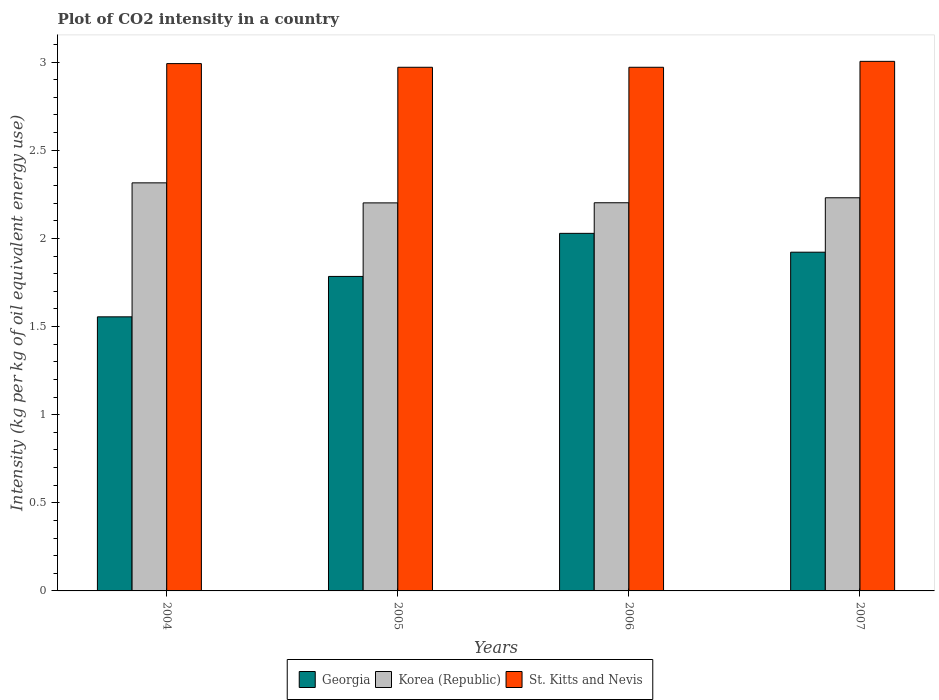How many different coloured bars are there?
Make the answer very short. 3. Are the number of bars per tick equal to the number of legend labels?
Keep it short and to the point. Yes. What is the label of the 2nd group of bars from the left?
Your answer should be compact. 2005. What is the CO2 intensity in in St. Kitts and Nevis in 2004?
Offer a terse response. 2.99. Across all years, what is the maximum CO2 intensity in in Korea (Republic)?
Provide a succinct answer. 2.32. Across all years, what is the minimum CO2 intensity in in Georgia?
Give a very brief answer. 1.55. In which year was the CO2 intensity in in Korea (Republic) minimum?
Offer a very short reply. 2005. What is the total CO2 intensity in in St. Kitts and Nevis in the graph?
Make the answer very short. 11.94. What is the difference between the CO2 intensity in in Georgia in 2004 and that in 2005?
Your response must be concise. -0.23. What is the difference between the CO2 intensity in in Georgia in 2005 and the CO2 intensity in in St. Kitts and Nevis in 2006?
Provide a short and direct response. -1.19. What is the average CO2 intensity in in Korea (Republic) per year?
Offer a terse response. 2.24. In the year 2004, what is the difference between the CO2 intensity in in St. Kitts and Nevis and CO2 intensity in in Korea (Republic)?
Offer a very short reply. 0.68. In how many years, is the CO2 intensity in in Korea (Republic) greater than 2.9 kg?
Keep it short and to the point. 0. What is the ratio of the CO2 intensity in in Korea (Republic) in 2004 to that in 2006?
Provide a short and direct response. 1.05. Is the difference between the CO2 intensity in in St. Kitts and Nevis in 2005 and 2006 greater than the difference between the CO2 intensity in in Korea (Republic) in 2005 and 2006?
Provide a short and direct response. Yes. What is the difference between the highest and the second highest CO2 intensity in in St. Kitts and Nevis?
Your response must be concise. 0.01. What is the difference between the highest and the lowest CO2 intensity in in Korea (Republic)?
Your answer should be very brief. 0.11. In how many years, is the CO2 intensity in in St. Kitts and Nevis greater than the average CO2 intensity in in St. Kitts and Nevis taken over all years?
Your answer should be compact. 2. What does the 1st bar from the left in 2007 represents?
Make the answer very short. Georgia. What does the 3rd bar from the right in 2007 represents?
Provide a succinct answer. Georgia. How many bars are there?
Provide a short and direct response. 12. Are all the bars in the graph horizontal?
Ensure brevity in your answer.  No. How many years are there in the graph?
Your answer should be very brief. 4. Are the values on the major ticks of Y-axis written in scientific E-notation?
Offer a very short reply. No. Does the graph contain grids?
Provide a succinct answer. No. How are the legend labels stacked?
Provide a succinct answer. Horizontal. What is the title of the graph?
Your answer should be very brief. Plot of CO2 intensity in a country. Does "Cambodia" appear as one of the legend labels in the graph?
Make the answer very short. No. What is the label or title of the Y-axis?
Keep it short and to the point. Intensity (kg per kg of oil equivalent energy use). What is the Intensity (kg per kg of oil equivalent energy use) of Georgia in 2004?
Your answer should be compact. 1.55. What is the Intensity (kg per kg of oil equivalent energy use) in Korea (Republic) in 2004?
Your answer should be very brief. 2.32. What is the Intensity (kg per kg of oil equivalent energy use) in St. Kitts and Nevis in 2004?
Offer a terse response. 2.99. What is the Intensity (kg per kg of oil equivalent energy use) in Georgia in 2005?
Ensure brevity in your answer.  1.78. What is the Intensity (kg per kg of oil equivalent energy use) in Korea (Republic) in 2005?
Provide a short and direct response. 2.2. What is the Intensity (kg per kg of oil equivalent energy use) of St. Kitts and Nevis in 2005?
Provide a succinct answer. 2.97. What is the Intensity (kg per kg of oil equivalent energy use) in Georgia in 2006?
Make the answer very short. 2.03. What is the Intensity (kg per kg of oil equivalent energy use) in Korea (Republic) in 2006?
Ensure brevity in your answer.  2.2. What is the Intensity (kg per kg of oil equivalent energy use) in St. Kitts and Nevis in 2006?
Make the answer very short. 2.97. What is the Intensity (kg per kg of oil equivalent energy use) in Georgia in 2007?
Provide a succinct answer. 1.92. What is the Intensity (kg per kg of oil equivalent energy use) of Korea (Republic) in 2007?
Keep it short and to the point. 2.23. What is the Intensity (kg per kg of oil equivalent energy use) of St. Kitts and Nevis in 2007?
Offer a terse response. 3. Across all years, what is the maximum Intensity (kg per kg of oil equivalent energy use) of Georgia?
Your answer should be compact. 2.03. Across all years, what is the maximum Intensity (kg per kg of oil equivalent energy use) in Korea (Republic)?
Ensure brevity in your answer.  2.32. Across all years, what is the maximum Intensity (kg per kg of oil equivalent energy use) in St. Kitts and Nevis?
Give a very brief answer. 3. Across all years, what is the minimum Intensity (kg per kg of oil equivalent energy use) in Georgia?
Make the answer very short. 1.55. Across all years, what is the minimum Intensity (kg per kg of oil equivalent energy use) in Korea (Republic)?
Ensure brevity in your answer.  2.2. Across all years, what is the minimum Intensity (kg per kg of oil equivalent energy use) in St. Kitts and Nevis?
Ensure brevity in your answer.  2.97. What is the total Intensity (kg per kg of oil equivalent energy use) in Georgia in the graph?
Ensure brevity in your answer.  7.29. What is the total Intensity (kg per kg of oil equivalent energy use) in Korea (Republic) in the graph?
Keep it short and to the point. 8.95. What is the total Intensity (kg per kg of oil equivalent energy use) in St. Kitts and Nevis in the graph?
Keep it short and to the point. 11.94. What is the difference between the Intensity (kg per kg of oil equivalent energy use) in Georgia in 2004 and that in 2005?
Offer a very short reply. -0.23. What is the difference between the Intensity (kg per kg of oil equivalent energy use) in Korea (Republic) in 2004 and that in 2005?
Provide a succinct answer. 0.11. What is the difference between the Intensity (kg per kg of oil equivalent energy use) of St. Kitts and Nevis in 2004 and that in 2005?
Ensure brevity in your answer.  0.02. What is the difference between the Intensity (kg per kg of oil equivalent energy use) in Georgia in 2004 and that in 2006?
Offer a terse response. -0.47. What is the difference between the Intensity (kg per kg of oil equivalent energy use) of Korea (Republic) in 2004 and that in 2006?
Your answer should be compact. 0.11. What is the difference between the Intensity (kg per kg of oil equivalent energy use) in St. Kitts and Nevis in 2004 and that in 2006?
Your answer should be compact. 0.02. What is the difference between the Intensity (kg per kg of oil equivalent energy use) of Georgia in 2004 and that in 2007?
Offer a very short reply. -0.37. What is the difference between the Intensity (kg per kg of oil equivalent energy use) in Korea (Republic) in 2004 and that in 2007?
Offer a terse response. 0.08. What is the difference between the Intensity (kg per kg of oil equivalent energy use) of St. Kitts and Nevis in 2004 and that in 2007?
Your answer should be very brief. -0.01. What is the difference between the Intensity (kg per kg of oil equivalent energy use) in Georgia in 2005 and that in 2006?
Make the answer very short. -0.24. What is the difference between the Intensity (kg per kg of oil equivalent energy use) of Korea (Republic) in 2005 and that in 2006?
Give a very brief answer. -0. What is the difference between the Intensity (kg per kg of oil equivalent energy use) of Georgia in 2005 and that in 2007?
Ensure brevity in your answer.  -0.14. What is the difference between the Intensity (kg per kg of oil equivalent energy use) of Korea (Republic) in 2005 and that in 2007?
Keep it short and to the point. -0.03. What is the difference between the Intensity (kg per kg of oil equivalent energy use) in St. Kitts and Nevis in 2005 and that in 2007?
Your response must be concise. -0.03. What is the difference between the Intensity (kg per kg of oil equivalent energy use) in Georgia in 2006 and that in 2007?
Offer a very short reply. 0.11. What is the difference between the Intensity (kg per kg of oil equivalent energy use) of Korea (Republic) in 2006 and that in 2007?
Your response must be concise. -0.03. What is the difference between the Intensity (kg per kg of oil equivalent energy use) of St. Kitts and Nevis in 2006 and that in 2007?
Keep it short and to the point. -0.03. What is the difference between the Intensity (kg per kg of oil equivalent energy use) of Georgia in 2004 and the Intensity (kg per kg of oil equivalent energy use) of Korea (Republic) in 2005?
Offer a terse response. -0.65. What is the difference between the Intensity (kg per kg of oil equivalent energy use) of Georgia in 2004 and the Intensity (kg per kg of oil equivalent energy use) of St. Kitts and Nevis in 2005?
Offer a terse response. -1.42. What is the difference between the Intensity (kg per kg of oil equivalent energy use) of Korea (Republic) in 2004 and the Intensity (kg per kg of oil equivalent energy use) of St. Kitts and Nevis in 2005?
Give a very brief answer. -0.66. What is the difference between the Intensity (kg per kg of oil equivalent energy use) of Georgia in 2004 and the Intensity (kg per kg of oil equivalent energy use) of Korea (Republic) in 2006?
Offer a very short reply. -0.65. What is the difference between the Intensity (kg per kg of oil equivalent energy use) of Georgia in 2004 and the Intensity (kg per kg of oil equivalent energy use) of St. Kitts and Nevis in 2006?
Give a very brief answer. -1.42. What is the difference between the Intensity (kg per kg of oil equivalent energy use) in Korea (Republic) in 2004 and the Intensity (kg per kg of oil equivalent energy use) in St. Kitts and Nevis in 2006?
Make the answer very short. -0.66. What is the difference between the Intensity (kg per kg of oil equivalent energy use) in Georgia in 2004 and the Intensity (kg per kg of oil equivalent energy use) in Korea (Republic) in 2007?
Offer a terse response. -0.68. What is the difference between the Intensity (kg per kg of oil equivalent energy use) in Georgia in 2004 and the Intensity (kg per kg of oil equivalent energy use) in St. Kitts and Nevis in 2007?
Offer a very short reply. -1.45. What is the difference between the Intensity (kg per kg of oil equivalent energy use) in Korea (Republic) in 2004 and the Intensity (kg per kg of oil equivalent energy use) in St. Kitts and Nevis in 2007?
Make the answer very short. -0.69. What is the difference between the Intensity (kg per kg of oil equivalent energy use) of Georgia in 2005 and the Intensity (kg per kg of oil equivalent energy use) of Korea (Republic) in 2006?
Your response must be concise. -0.42. What is the difference between the Intensity (kg per kg of oil equivalent energy use) in Georgia in 2005 and the Intensity (kg per kg of oil equivalent energy use) in St. Kitts and Nevis in 2006?
Ensure brevity in your answer.  -1.19. What is the difference between the Intensity (kg per kg of oil equivalent energy use) of Korea (Republic) in 2005 and the Intensity (kg per kg of oil equivalent energy use) of St. Kitts and Nevis in 2006?
Your answer should be very brief. -0.77. What is the difference between the Intensity (kg per kg of oil equivalent energy use) in Georgia in 2005 and the Intensity (kg per kg of oil equivalent energy use) in Korea (Republic) in 2007?
Offer a terse response. -0.45. What is the difference between the Intensity (kg per kg of oil equivalent energy use) in Georgia in 2005 and the Intensity (kg per kg of oil equivalent energy use) in St. Kitts and Nevis in 2007?
Offer a very short reply. -1.22. What is the difference between the Intensity (kg per kg of oil equivalent energy use) in Korea (Republic) in 2005 and the Intensity (kg per kg of oil equivalent energy use) in St. Kitts and Nevis in 2007?
Provide a succinct answer. -0.8. What is the difference between the Intensity (kg per kg of oil equivalent energy use) in Georgia in 2006 and the Intensity (kg per kg of oil equivalent energy use) in Korea (Republic) in 2007?
Your answer should be very brief. -0.2. What is the difference between the Intensity (kg per kg of oil equivalent energy use) of Georgia in 2006 and the Intensity (kg per kg of oil equivalent energy use) of St. Kitts and Nevis in 2007?
Provide a short and direct response. -0.98. What is the difference between the Intensity (kg per kg of oil equivalent energy use) in Korea (Republic) in 2006 and the Intensity (kg per kg of oil equivalent energy use) in St. Kitts and Nevis in 2007?
Provide a succinct answer. -0.8. What is the average Intensity (kg per kg of oil equivalent energy use) of Georgia per year?
Give a very brief answer. 1.82. What is the average Intensity (kg per kg of oil equivalent energy use) of Korea (Republic) per year?
Give a very brief answer. 2.24. What is the average Intensity (kg per kg of oil equivalent energy use) in St. Kitts and Nevis per year?
Your response must be concise. 2.98. In the year 2004, what is the difference between the Intensity (kg per kg of oil equivalent energy use) of Georgia and Intensity (kg per kg of oil equivalent energy use) of Korea (Republic)?
Make the answer very short. -0.76. In the year 2004, what is the difference between the Intensity (kg per kg of oil equivalent energy use) in Georgia and Intensity (kg per kg of oil equivalent energy use) in St. Kitts and Nevis?
Offer a very short reply. -1.44. In the year 2004, what is the difference between the Intensity (kg per kg of oil equivalent energy use) in Korea (Republic) and Intensity (kg per kg of oil equivalent energy use) in St. Kitts and Nevis?
Offer a terse response. -0.68. In the year 2005, what is the difference between the Intensity (kg per kg of oil equivalent energy use) of Georgia and Intensity (kg per kg of oil equivalent energy use) of Korea (Republic)?
Keep it short and to the point. -0.42. In the year 2005, what is the difference between the Intensity (kg per kg of oil equivalent energy use) of Georgia and Intensity (kg per kg of oil equivalent energy use) of St. Kitts and Nevis?
Offer a terse response. -1.19. In the year 2005, what is the difference between the Intensity (kg per kg of oil equivalent energy use) of Korea (Republic) and Intensity (kg per kg of oil equivalent energy use) of St. Kitts and Nevis?
Your answer should be very brief. -0.77. In the year 2006, what is the difference between the Intensity (kg per kg of oil equivalent energy use) of Georgia and Intensity (kg per kg of oil equivalent energy use) of Korea (Republic)?
Make the answer very short. -0.17. In the year 2006, what is the difference between the Intensity (kg per kg of oil equivalent energy use) in Georgia and Intensity (kg per kg of oil equivalent energy use) in St. Kitts and Nevis?
Make the answer very short. -0.94. In the year 2006, what is the difference between the Intensity (kg per kg of oil equivalent energy use) in Korea (Republic) and Intensity (kg per kg of oil equivalent energy use) in St. Kitts and Nevis?
Offer a terse response. -0.77. In the year 2007, what is the difference between the Intensity (kg per kg of oil equivalent energy use) of Georgia and Intensity (kg per kg of oil equivalent energy use) of Korea (Republic)?
Give a very brief answer. -0.31. In the year 2007, what is the difference between the Intensity (kg per kg of oil equivalent energy use) of Georgia and Intensity (kg per kg of oil equivalent energy use) of St. Kitts and Nevis?
Give a very brief answer. -1.08. In the year 2007, what is the difference between the Intensity (kg per kg of oil equivalent energy use) in Korea (Republic) and Intensity (kg per kg of oil equivalent energy use) in St. Kitts and Nevis?
Your answer should be very brief. -0.77. What is the ratio of the Intensity (kg per kg of oil equivalent energy use) in Georgia in 2004 to that in 2005?
Your response must be concise. 0.87. What is the ratio of the Intensity (kg per kg of oil equivalent energy use) of Korea (Republic) in 2004 to that in 2005?
Your answer should be very brief. 1.05. What is the ratio of the Intensity (kg per kg of oil equivalent energy use) of St. Kitts and Nevis in 2004 to that in 2005?
Ensure brevity in your answer.  1.01. What is the ratio of the Intensity (kg per kg of oil equivalent energy use) of Georgia in 2004 to that in 2006?
Offer a terse response. 0.77. What is the ratio of the Intensity (kg per kg of oil equivalent energy use) in Korea (Republic) in 2004 to that in 2006?
Offer a terse response. 1.05. What is the ratio of the Intensity (kg per kg of oil equivalent energy use) in St. Kitts and Nevis in 2004 to that in 2006?
Provide a short and direct response. 1.01. What is the ratio of the Intensity (kg per kg of oil equivalent energy use) of Georgia in 2004 to that in 2007?
Provide a short and direct response. 0.81. What is the ratio of the Intensity (kg per kg of oil equivalent energy use) of Korea (Republic) in 2004 to that in 2007?
Provide a short and direct response. 1.04. What is the ratio of the Intensity (kg per kg of oil equivalent energy use) of Georgia in 2005 to that in 2006?
Provide a succinct answer. 0.88. What is the ratio of the Intensity (kg per kg of oil equivalent energy use) of Korea (Republic) in 2005 to that in 2006?
Offer a terse response. 1. What is the ratio of the Intensity (kg per kg of oil equivalent energy use) of Georgia in 2005 to that in 2007?
Offer a terse response. 0.93. What is the ratio of the Intensity (kg per kg of oil equivalent energy use) in Georgia in 2006 to that in 2007?
Provide a succinct answer. 1.06. What is the ratio of the Intensity (kg per kg of oil equivalent energy use) of Korea (Republic) in 2006 to that in 2007?
Provide a short and direct response. 0.99. What is the difference between the highest and the second highest Intensity (kg per kg of oil equivalent energy use) of Georgia?
Keep it short and to the point. 0.11. What is the difference between the highest and the second highest Intensity (kg per kg of oil equivalent energy use) of Korea (Republic)?
Your response must be concise. 0.08. What is the difference between the highest and the second highest Intensity (kg per kg of oil equivalent energy use) in St. Kitts and Nevis?
Offer a terse response. 0.01. What is the difference between the highest and the lowest Intensity (kg per kg of oil equivalent energy use) of Georgia?
Keep it short and to the point. 0.47. What is the difference between the highest and the lowest Intensity (kg per kg of oil equivalent energy use) in Korea (Republic)?
Provide a short and direct response. 0.11. What is the difference between the highest and the lowest Intensity (kg per kg of oil equivalent energy use) in St. Kitts and Nevis?
Your response must be concise. 0.03. 